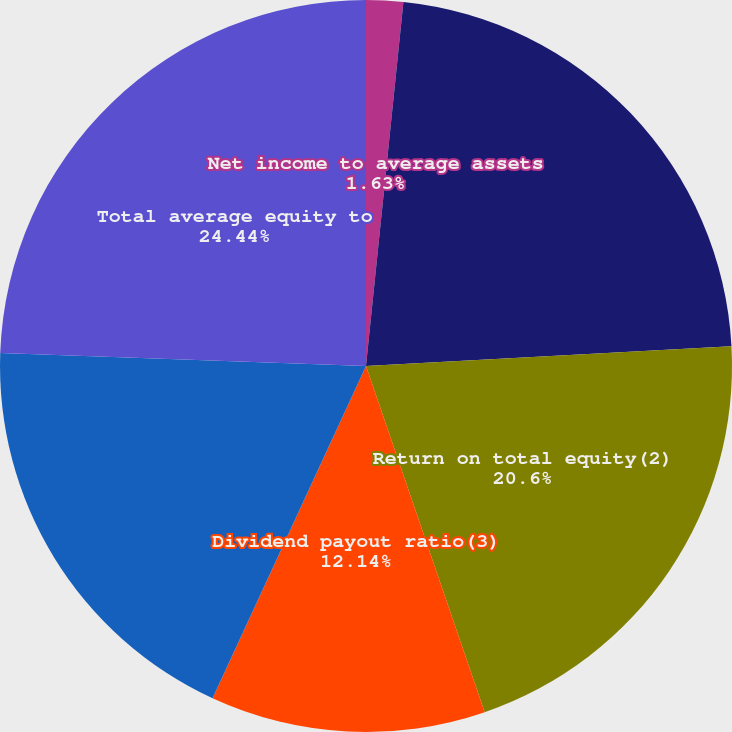Convert chart. <chart><loc_0><loc_0><loc_500><loc_500><pie_chart><fcel>Net income to average assets<fcel>Return on average common<fcel>Return on total equity(2)<fcel>Dividend payout ratio(3)<fcel>Total average common equity to<fcel>Total average equity to<nl><fcel>1.63%<fcel>22.51%<fcel>20.6%<fcel>12.14%<fcel>18.68%<fcel>24.43%<nl></chart> 